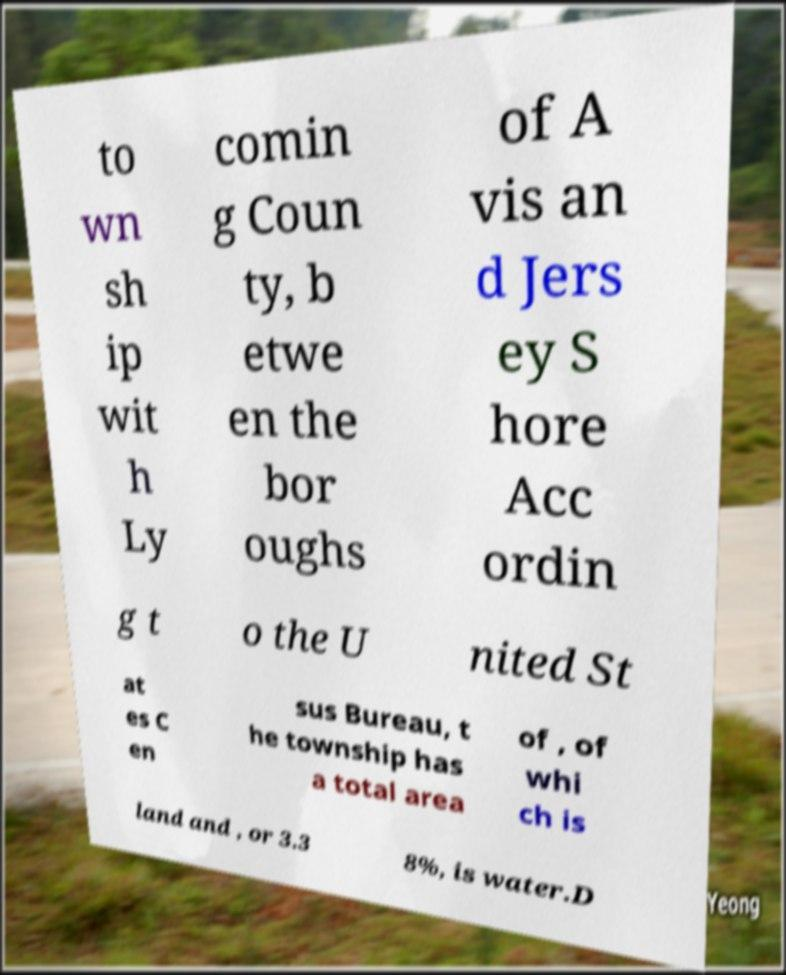Can you read and provide the text displayed in the image?This photo seems to have some interesting text. Can you extract and type it out for me? to wn sh ip wit h Ly comin g Coun ty, b etwe en the bor oughs of A vis an d Jers ey S hore Acc ordin g t o the U nited St at es C en sus Bureau, t he township has a total area of , of whi ch is land and , or 3.3 8%, is water.D 